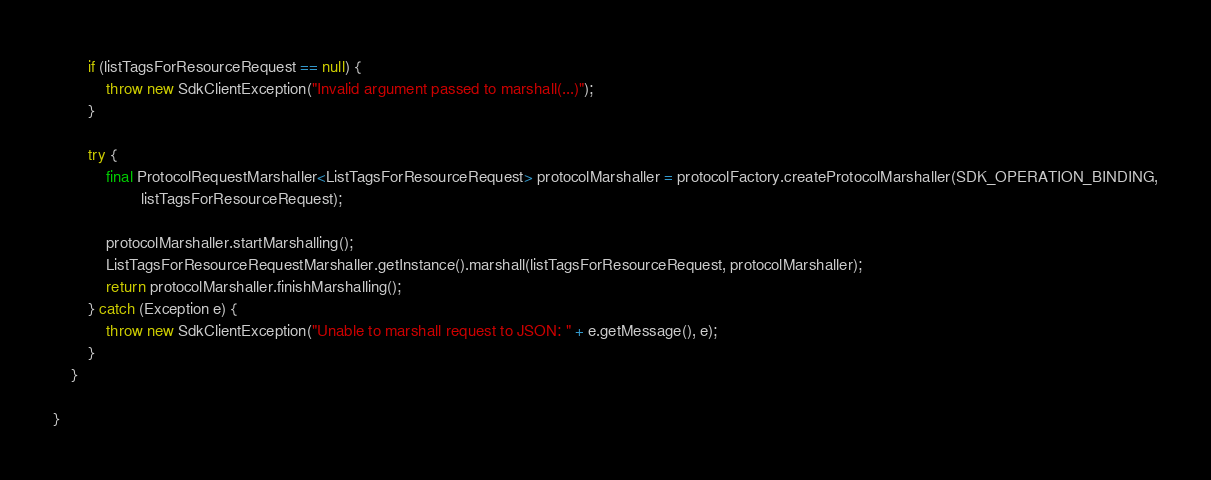Convert code to text. <code><loc_0><loc_0><loc_500><loc_500><_Java_>        if (listTagsForResourceRequest == null) {
            throw new SdkClientException("Invalid argument passed to marshall(...)");
        }

        try {
            final ProtocolRequestMarshaller<ListTagsForResourceRequest> protocolMarshaller = protocolFactory.createProtocolMarshaller(SDK_OPERATION_BINDING,
                    listTagsForResourceRequest);

            protocolMarshaller.startMarshalling();
            ListTagsForResourceRequestMarshaller.getInstance().marshall(listTagsForResourceRequest, protocolMarshaller);
            return protocolMarshaller.finishMarshalling();
        } catch (Exception e) {
            throw new SdkClientException("Unable to marshall request to JSON: " + e.getMessage(), e);
        }
    }

}
</code> 